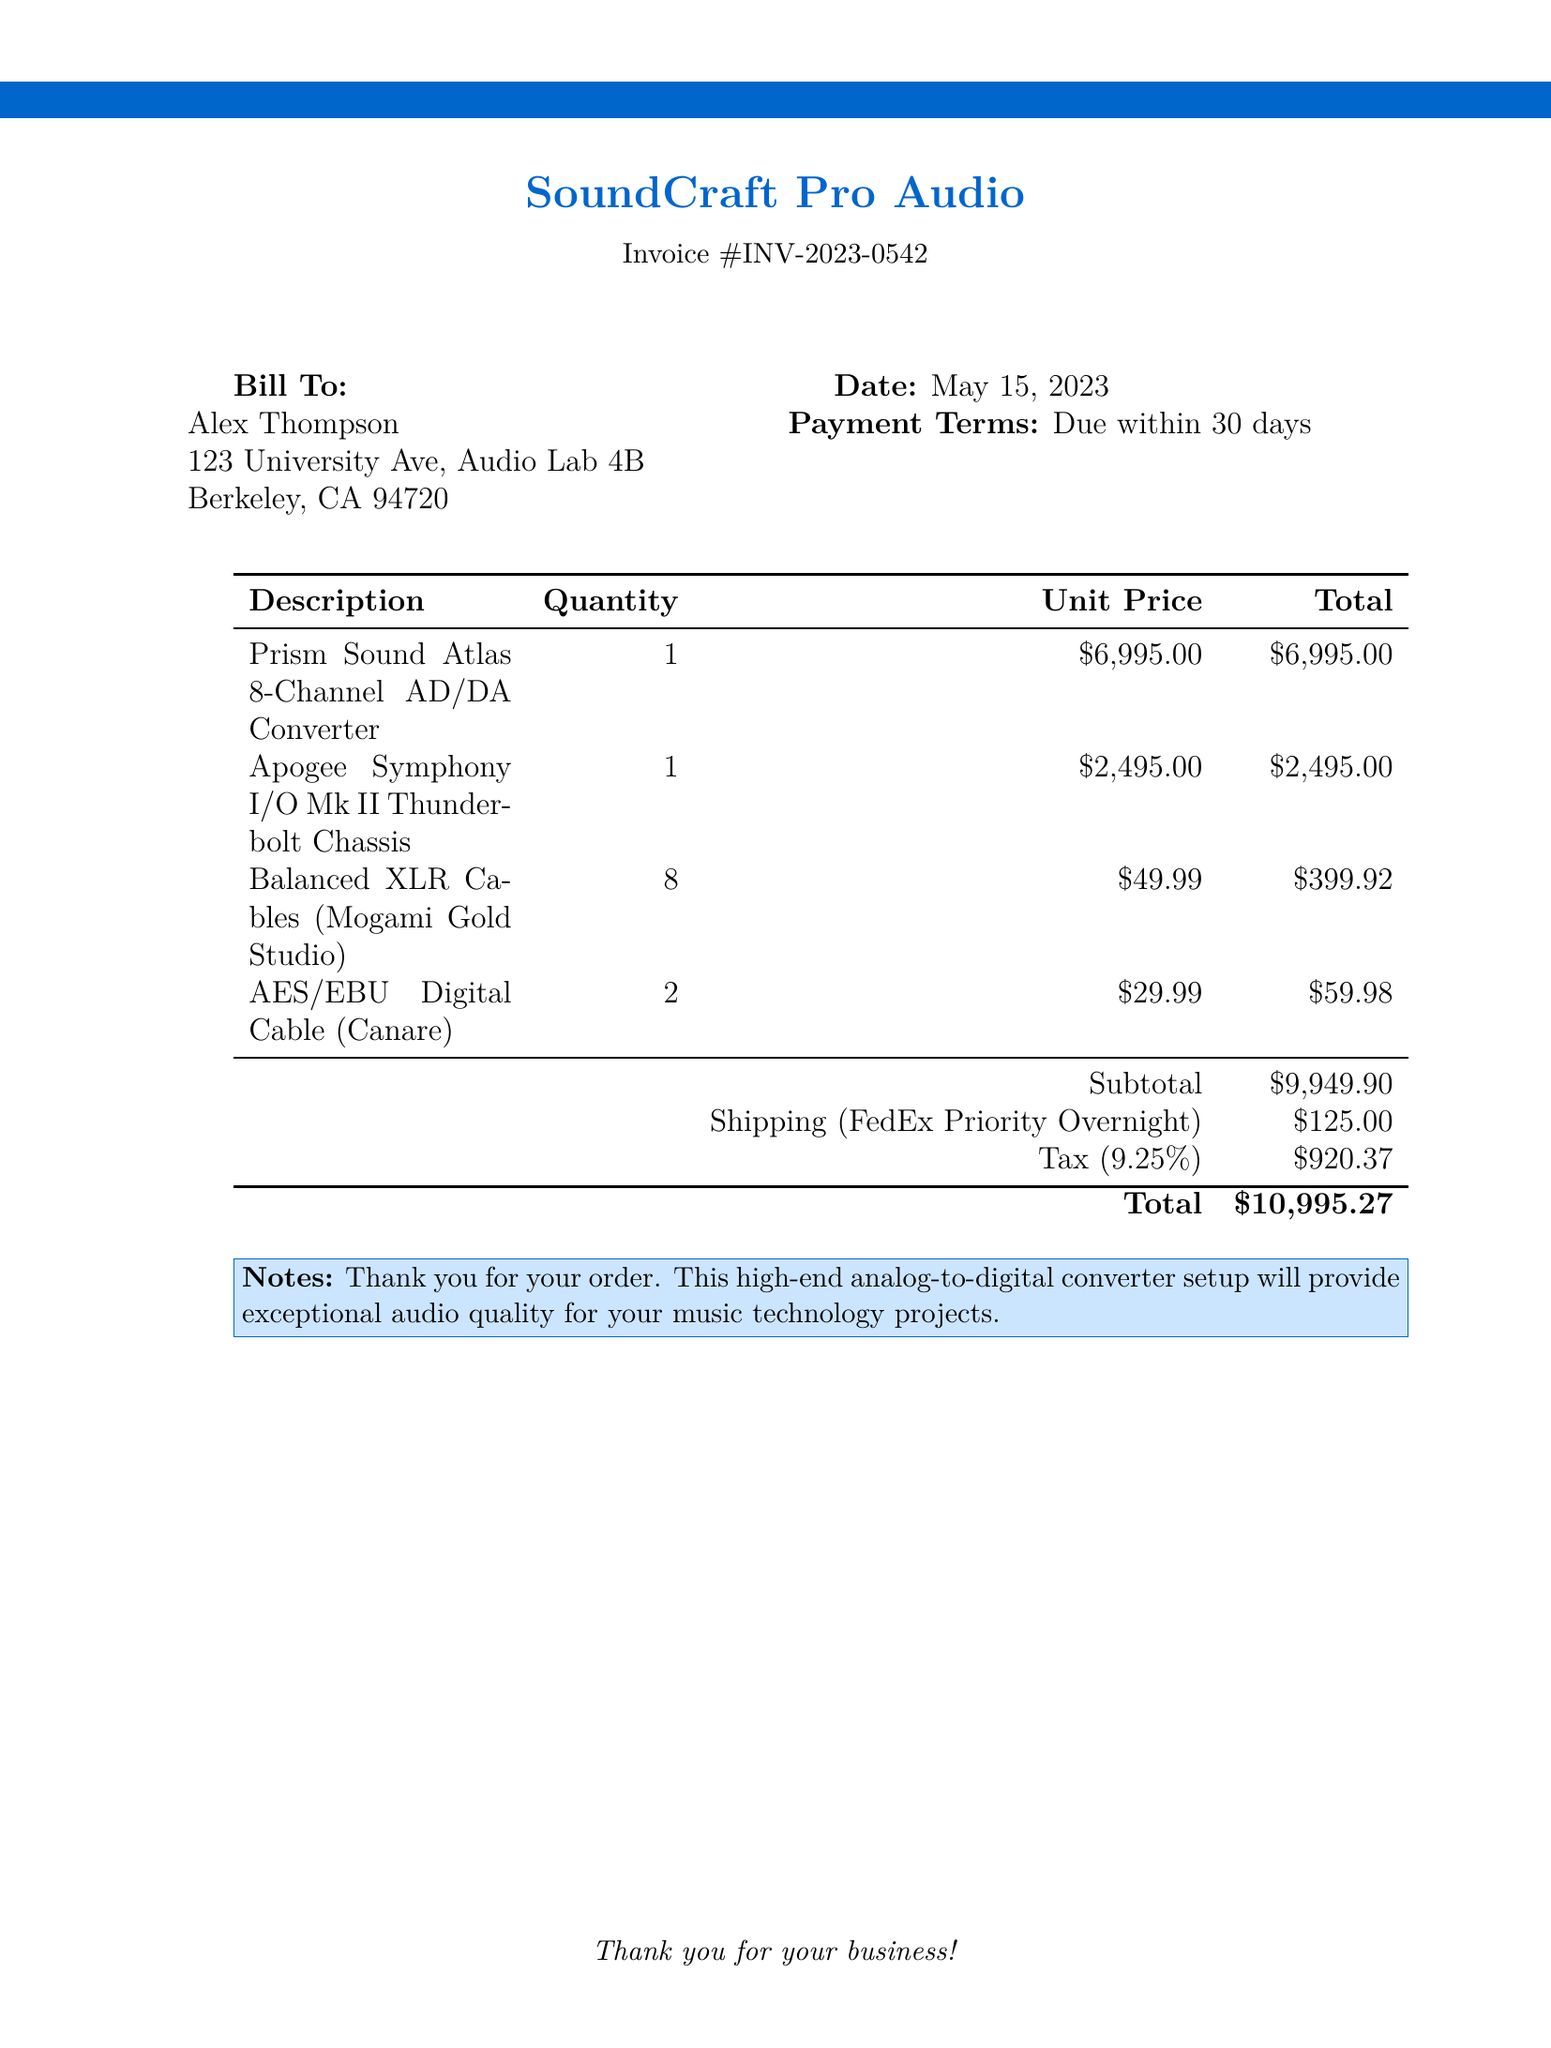what is the invoice number? The document specifies the invoice number clearly in the header as INV-2023-0542.
Answer: INV-2023-0542 who is the bill to? The recipient of the invoice, or the bill to, is mentioned as Alex Thompson.
Answer: Alex Thompson what is the subtotal amount? The subtotal is clearly listed in the table before adding taxes and shipping costs.
Answer: $9,949.90 how much is the tax? The tax amount can be found in the invoice as part of the summary section.
Answer: $920.37 what is the shipping method used? The shipping method is explicitly stated in the invoice as FedEx Priority Overnight.
Answer: FedEx Priority Overnight how many Balanced XLR Cables were ordered? The quantity of Balanced XLR Cables is mentioned in the description section of the invoice.
Answer: 8 what is the total amount due? The total amount due is calculated and presented at the bottom of the invoice.
Answer: $10,995.27 what is the date of the invoice? The date of the invoice is specified clearly in the document, under the billing information.
Answer: May 15, 2023 what is included in the notes section? The notes section provides a brief message of appreciation and the purpose of the product.
Answer: Thank you for your order. This high-end analog-to-digital converter setup will provide exceptional audio quality for your music technology projects 